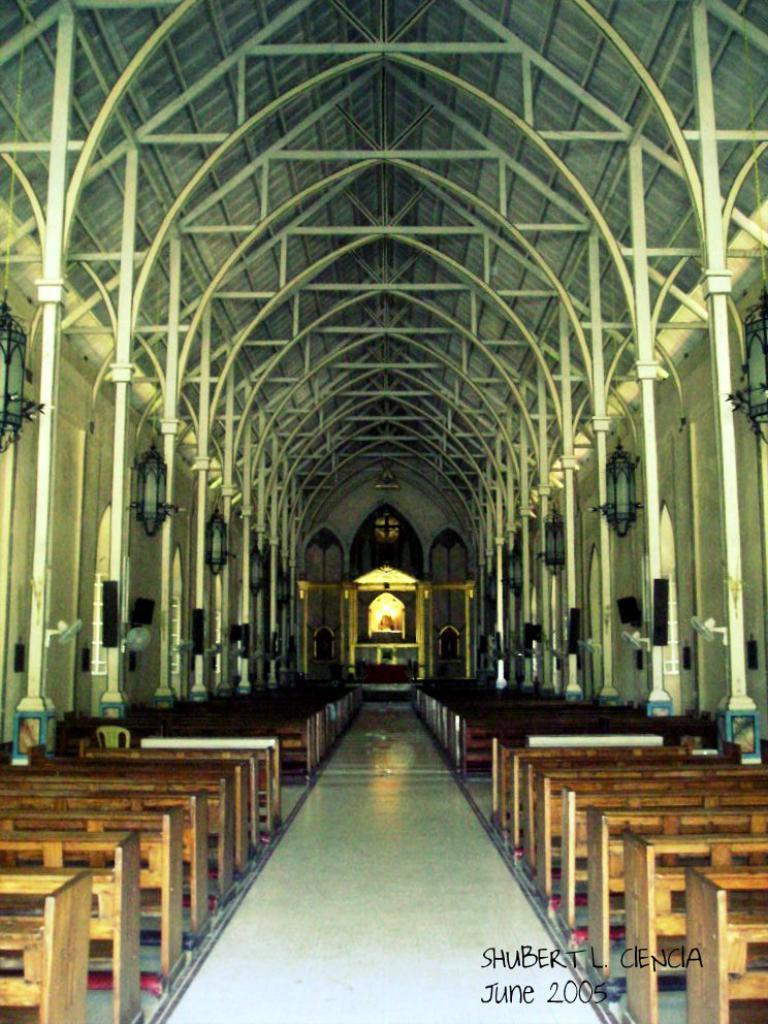<image>
Describe the image concisely. A photo of a church is from June 2005. 